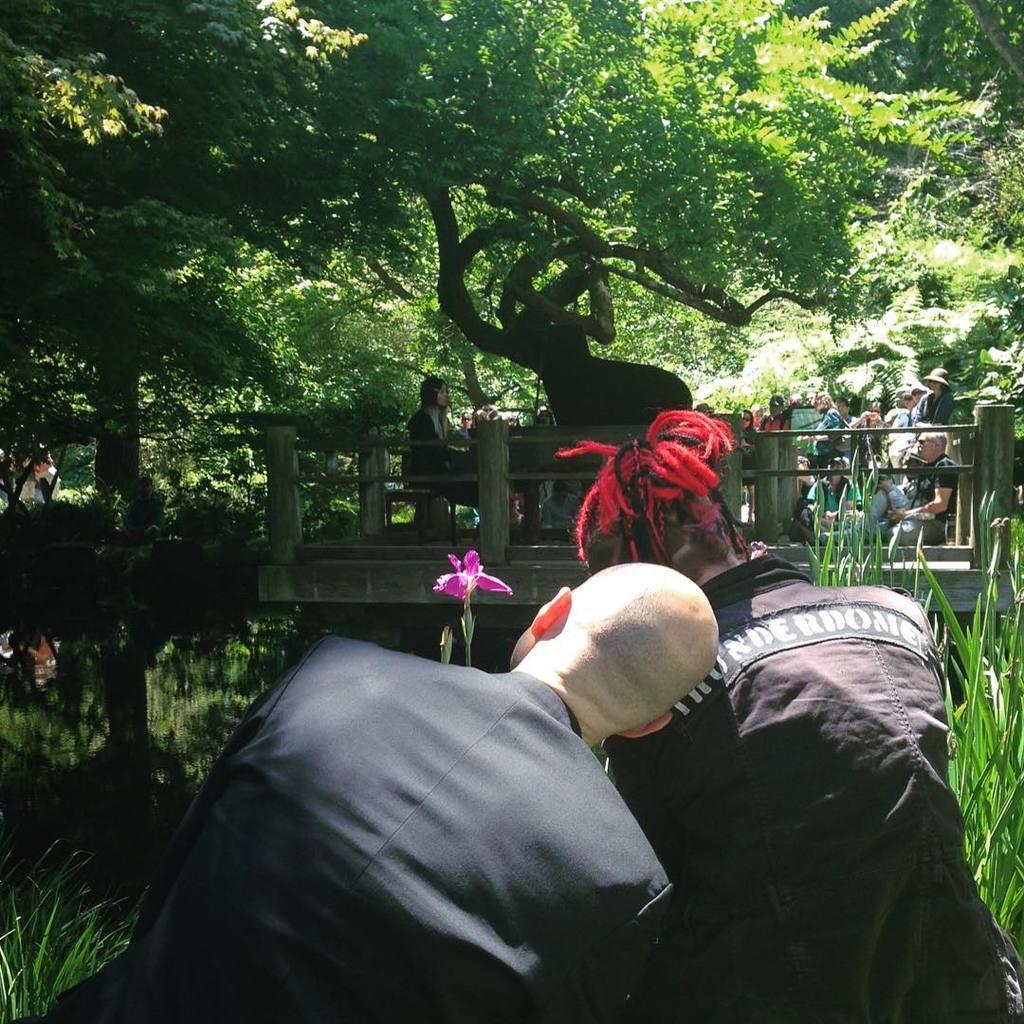Can you describe this image briefly? In this image we can see two persons. Near to them there is grass. Also there is water. In the back there is a bridge with railings. And there are people. In the background there are trees. 